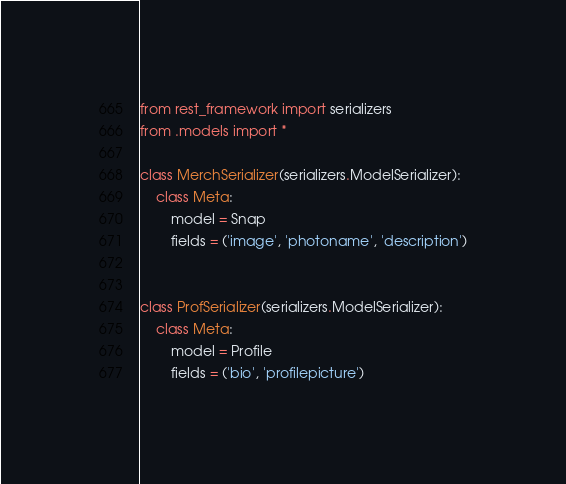Convert code to text. <code><loc_0><loc_0><loc_500><loc_500><_Python_>from rest_framework import serializers
from .models import *

class MerchSerializer(serializers.ModelSerializer):
    class Meta:
        model = Snap
        fields = ('image', 'photoname', 'description')


class ProfSerializer(serializers.ModelSerializer):
    class Meta:
        model = Profile
        fields = ('bio', 'profilepicture')

</code> 